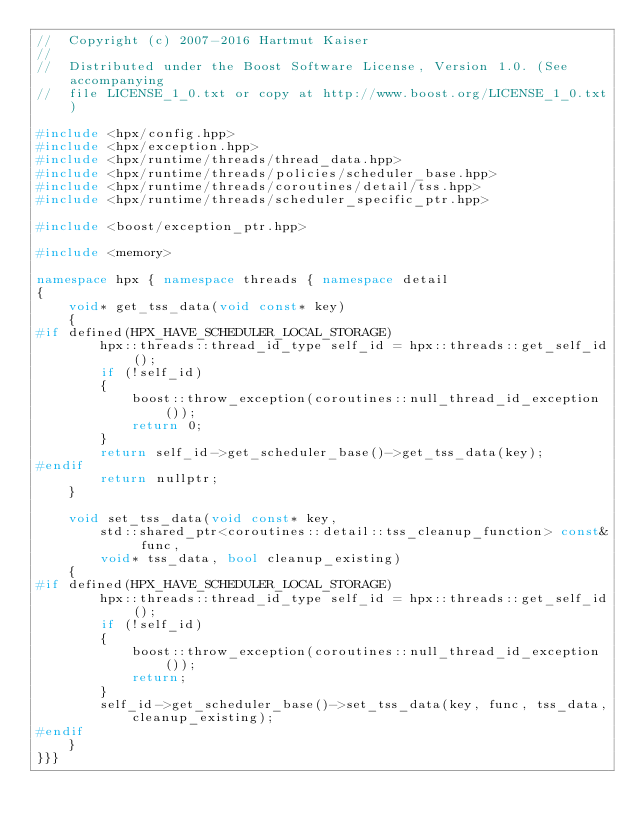Convert code to text. <code><loc_0><loc_0><loc_500><loc_500><_C++_>//  Copyright (c) 2007-2016 Hartmut Kaiser
//
//  Distributed under the Boost Software License, Version 1.0. (See accompanying
//  file LICENSE_1_0.txt or copy at http://www.boost.org/LICENSE_1_0.txt)

#include <hpx/config.hpp>
#include <hpx/exception.hpp>
#include <hpx/runtime/threads/thread_data.hpp>
#include <hpx/runtime/threads/policies/scheduler_base.hpp>
#include <hpx/runtime/threads/coroutines/detail/tss.hpp>
#include <hpx/runtime/threads/scheduler_specific_ptr.hpp>

#include <boost/exception_ptr.hpp>

#include <memory>

namespace hpx { namespace threads { namespace detail
{
    void* get_tss_data(void const* key)
    {
#if defined(HPX_HAVE_SCHEDULER_LOCAL_STORAGE)
        hpx::threads::thread_id_type self_id = hpx::threads::get_self_id();
        if (!self_id)
        {
            boost::throw_exception(coroutines::null_thread_id_exception());
            return 0;
        }
        return self_id->get_scheduler_base()->get_tss_data(key);
#endif
        return nullptr;
    }

    void set_tss_data(void const* key,
        std::shared_ptr<coroutines::detail::tss_cleanup_function> const& func,
        void* tss_data, bool cleanup_existing)
    {
#if defined(HPX_HAVE_SCHEDULER_LOCAL_STORAGE)
        hpx::threads::thread_id_type self_id = hpx::threads::get_self_id();
        if (!self_id)
        {
            boost::throw_exception(coroutines::null_thread_id_exception());
            return;
        }
        self_id->get_scheduler_base()->set_tss_data(key, func, tss_data,
            cleanup_existing);
#endif
    }
}}}
</code> 